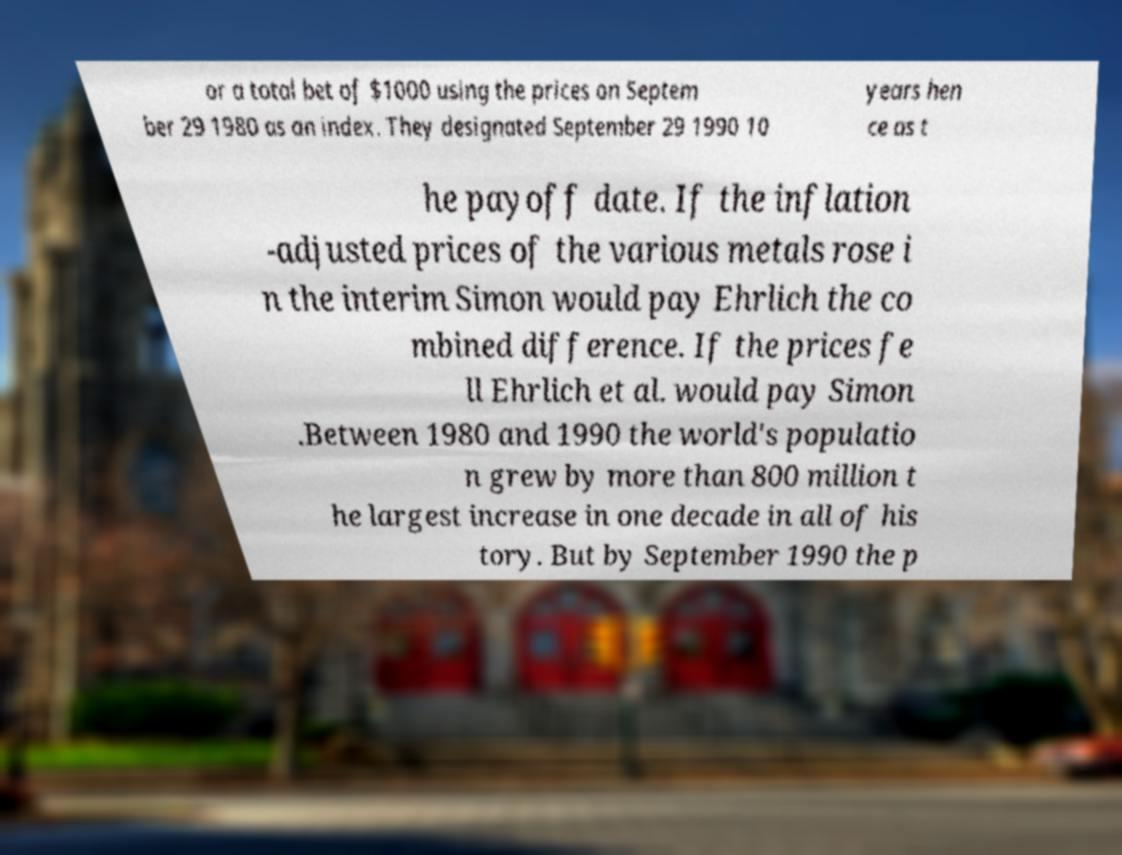Could you extract and type out the text from this image? or a total bet of $1000 using the prices on Septem ber 29 1980 as an index. They designated September 29 1990 10 years hen ce as t he payoff date. If the inflation -adjusted prices of the various metals rose i n the interim Simon would pay Ehrlich the co mbined difference. If the prices fe ll Ehrlich et al. would pay Simon .Between 1980 and 1990 the world's populatio n grew by more than 800 million t he largest increase in one decade in all of his tory. But by September 1990 the p 